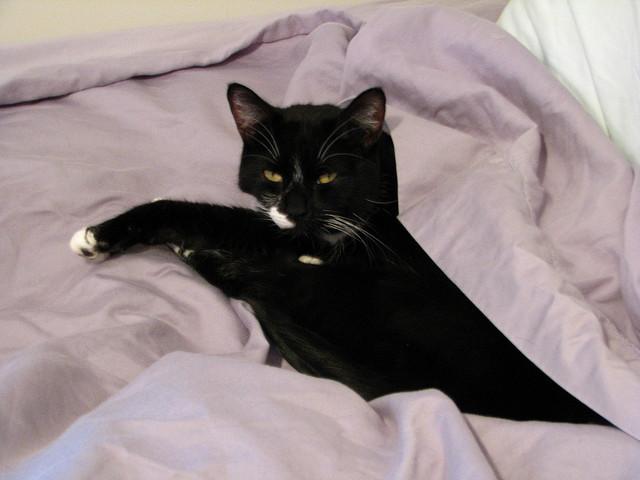What color is the cat?
Give a very brief answer. Black. Does the cat look happy?
Concise answer only. No. Is the cat asleep?
Quick response, please. No. What color are the sheets?
Short answer required. Gray. 